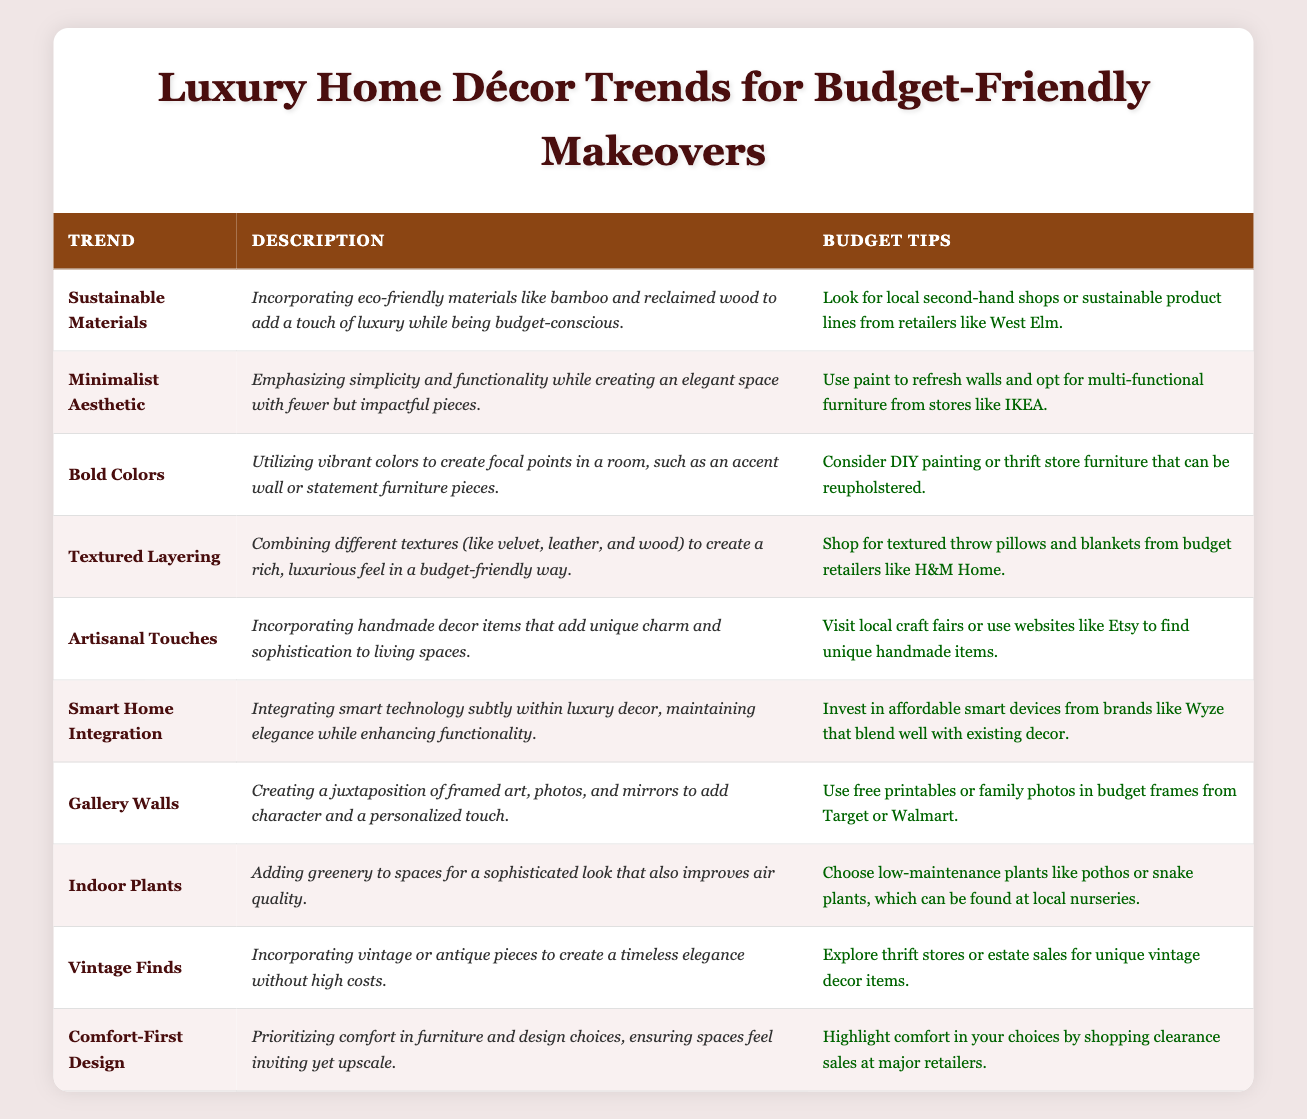What is the trend that incorporates eco-friendly materials? The table indicates that "Sustainable Materials" is the trend focused on eco-friendly materials.
Answer: Sustainable Materials Which trend suggests using paint to refresh walls? The trend "Minimalist Aesthetic" mentions using paint as part of its budget tips to create an elegant space.
Answer: Minimalist Aesthetic How many trends include specific suggestions for plants? The only trend that focuses on plants is "Indoor Plants," as it directly discusses adding greenery to spaces. Therefore, there is just one trend.
Answer: 1 Is there a trend related to integrating smart technology within luxury decor? Yes, the table lists "Smart Home Integration" as a trend that integrates smart technology while maintaining elegance.
Answer: Yes Which budget tip advises visiting local craft fairs for uniqueness? The trend "Artisanal Touches" includes the advice of visiting local craft fairs to find unique handmade items.
Answer: Artisanal Touches What are the two trends that emphasize enhancing comfort in design? The trends focusing on comfort are "Comfort-First Design," which prioritizes comfort in furniture, and "Textured Layering," which adds luxurious textures that often enhance comfort.
Answer: Comfort-First Design, Textured Layering Count the number of trends that suggest thrift store shopping to achieve luxury on a budget. "Bold Colors," "Textured Layering," and "Vintage Finds" all suggest thrift store shopping, making a total of three trends.
Answer: 3 Which trend recommends using vibrant colors as a defining characteristic? The trend "Bold Colors" is directly associated with the recommendation to use vibrant colors to create focal points in a room.
Answer: Bold Colors Explain how to create a gallery wall according to the table. The trend "Gallery Walls" explains that to create a gallery wall, you should juxtapose framed art, photos, and mirrors for a personalized touch. Budget tips include using free printables or family photos in budget frames.
Answer: Use framed art, photos, and mirrors; incorporate free printables or family photos in budget frames 